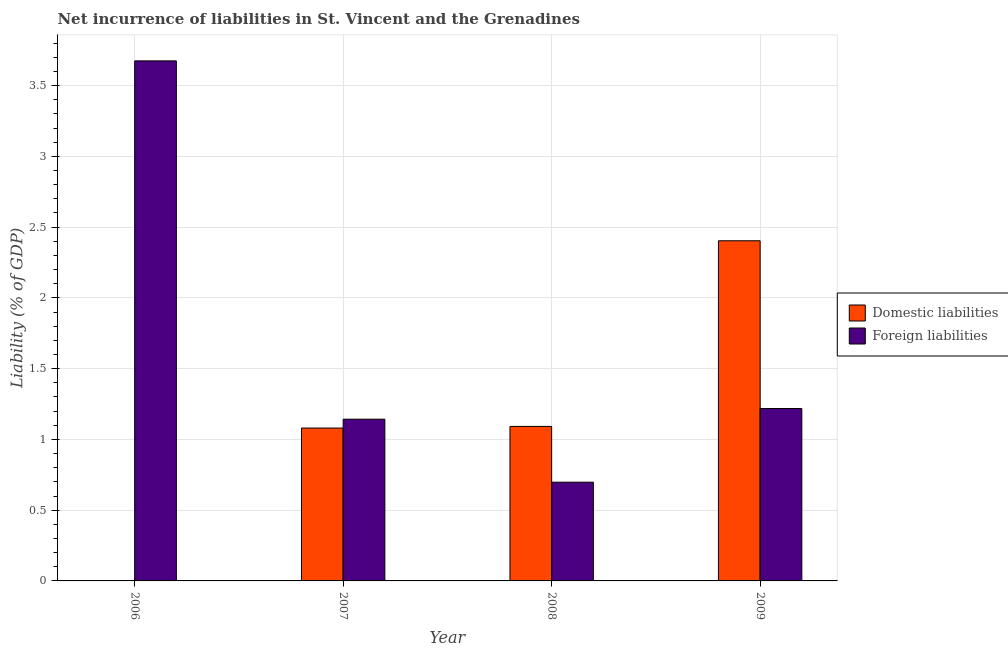Are the number of bars on each tick of the X-axis equal?
Provide a short and direct response. No. How many bars are there on the 1st tick from the left?
Make the answer very short. 1. How many bars are there on the 2nd tick from the right?
Make the answer very short. 2. What is the label of the 4th group of bars from the left?
Provide a short and direct response. 2009. What is the incurrence of domestic liabilities in 2008?
Your answer should be compact. 1.09. Across all years, what is the maximum incurrence of foreign liabilities?
Your answer should be compact. 3.67. Across all years, what is the minimum incurrence of foreign liabilities?
Keep it short and to the point. 0.7. In which year was the incurrence of foreign liabilities maximum?
Your answer should be compact. 2006. What is the total incurrence of domestic liabilities in the graph?
Your answer should be compact. 4.58. What is the difference between the incurrence of foreign liabilities in 2007 and that in 2008?
Give a very brief answer. 0.45. What is the difference between the incurrence of domestic liabilities in 2009 and the incurrence of foreign liabilities in 2008?
Your response must be concise. 1.31. What is the average incurrence of foreign liabilities per year?
Offer a terse response. 1.68. In the year 2009, what is the difference between the incurrence of domestic liabilities and incurrence of foreign liabilities?
Provide a short and direct response. 0. In how many years, is the incurrence of foreign liabilities greater than 1.8 %?
Make the answer very short. 1. What is the ratio of the incurrence of domestic liabilities in 2007 to that in 2008?
Offer a very short reply. 0.99. Is the incurrence of foreign liabilities in 2008 less than that in 2009?
Ensure brevity in your answer.  Yes. What is the difference between the highest and the second highest incurrence of foreign liabilities?
Your answer should be very brief. 2.46. What is the difference between the highest and the lowest incurrence of domestic liabilities?
Keep it short and to the point. 2.4. Is the sum of the incurrence of foreign liabilities in 2008 and 2009 greater than the maximum incurrence of domestic liabilities across all years?
Ensure brevity in your answer.  No. How many bars are there?
Provide a short and direct response. 7. Are all the bars in the graph horizontal?
Provide a short and direct response. No. What is the difference between two consecutive major ticks on the Y-axis?
Ensure brevity in your answer.  0.5. Does the graph contain any zero values?
Ensure brevity in your answer.  Yes. Does the graph contain grids?
Give a very brief answer. Yes. Where does the legend appear in the graph?
Offer a terse response. Center right. What is the title of the graph?
Provide a short and direct response. Net incurrence of liabilities in St. Vincent and the Grenadines. Does "Secondary" appear as one of the legend labels in the graph?
Provide a succinct answer. No. What is the label or title of the Y-axis?
Give a very brief answer. Liability (% of GDP). What is the Liability (% of GDP) in Domestic liabilities in 2006?
Your response must be concise. 0. What is the Liability (% of GDP) of Foreign liabilities in 2006?
Offer a very short reply. 3.67. What is the Liability (% of GDP) in Domestic liabilities in 2007?
Offer a terse response. 1.08. What is the Liability (% of GDP) in Foreign liabilities in 2007?
Keep it short and to the point. 1.14. What is the Liability (% of GDP) in Domestic liabilities in 2008?
Provide a succinct answer. 1.09. What is the Liability (% of GDP) in Foreign liabilities in 2008?
Keep it short and to the point. 0.7. What is the Liability (% of GDP) of Domestic liabilities in 2009?
Make the answer very short. 2.4. What is the Liability (% of GDP) in Foreign liabilities in 2009?
Offer a very short reply. 1.22. Across all years, what is the maximum Liability (% of GDP) of Domestic liabilities?
Your response must be concise. 2.4. Across all years, what is the maximum Liability (% of GDP) in Foreign liabilities?
Your response must be concise. 3.67. Across all years, what is the minimum Liability (% of GDP) of Domestic liabilities?
Provide a short and direct response. 0. Across all years, what is the minimum Liability (% of GDP) in Foreign liabilities?
Offer a very short reply. 0.7. What is the total Liability (% of GDP) of Domestic liabilities in the graph?
Offer a terse response. 4.58. What is the total Liability (% of GDP) in Foreign liabilities in the graph?
Keep it short and to the point. 6.73. What is the difference between the Liability (% of GDP) in Foreign liabilities in 2006 and that in 2007?
Provide a succinct answer. 2.53. What is the difference between the Liability (% of GDP) of Foreign liabilities in 2006 and that in 2008?
Make the answer very short. 2.98. What is the difference between the Liability (% of GDP) of Foreign liabilities in 2006 and that in 2009?
Your answer should be very brief. 2.46. What is the difference between the Liability (% of GDP) of Domestic liabilities in 2007 and that in 2008?
Keep it short and to the point. -0.01. What is the difference between the Liability (% of GDP) of Foreign liabilities in 2007 and that in 2008?
Your answer should be very brief. 0.45. What is the difference between the Liability (% of GDP) of Domestic liabilities in 2007 and that in 2009?
Keep it short and to the point. -1.32. What is the difference between the Liability (% of GDP) of Foreign liabilities in 2007 and that in 2009?
Ensure brevity in your answer.  -0.08. What is the difference between the Liability (% of GDP) in Domestic liabilities in 2008 and that in 2009?
Your answer should be compact. -1.31. What is the difference between the Liability (% of GDP) of Foreign liabilities in 2008 and that in 2009?
Provide a short and direct response. -0.52. What is the difference between the Liability (% of GDP) in Domestic liabilities in 2007 and the Liability (% of GDP) in Foreign liabilities in 2008?
Give a very brief answer. 0.38. What is the difference between the Liability (% of GDP) of Domestic liabilities in 2007 and the Liability (% of GDP) of Foreign liabilities in 2009?
Keep it short and to the point. -0.14. What is the difference between the Liability (% of GDP) in Domestic liabilities in 2008 and the Liability (% of GDP) in Foreign liabilities in 2009?
Give a very brief answer. -0.13. What is the average Liability (% of GDP) in Domestic liabilities per year?
Keep it short and to the point. 1.14. What is the average Liability (% of GDP) of Foreign liabilities per year?
Provide a succinct answer. 1.68. In the year 2007, what is the difference between the Liability (% of GDP) of Domestic liabilities and Liability (% of GDP) of Foreign liabilities?
Ensure brevity in your answer.  -0.06. In the year 2008, what is the difference between the Liability (% of GDP) in Domestic liabilities and Liability (% of GDP) in Foreign liabilities?
Offer a terse response. 0.39. In the year 2009, what is the difference between the Liability (% of GDP) of Domestic liabilities and Liability (% of GDP) of Foreign liabilities?
Provide a succinct answer. 1.19. What is the ratio of the Liability (% of GDP) in Foreign liabilities in 2006 to that in 2007?
Ensure brevity in your answer.  3.22. What is the ratio of the Liability (% of GDP) of Foreign liabilities in 2006 to that in 2008?
Provide a short and direct response. 5.27. What is the ratio of the Liability (% of GDP) in Foreign liabilities in 2006 to that in 2009?
Give a very brief answer. 3.02. What is the ratio of the Liability (% of GDP) in Foreign liabilities in 2007 to that in 2008?
Make the answer very short. 1.64. What is the ratio of the Liability (% of GDP) in Domestic liabilities in 2007 to that in 2009?
Ensure brevity in your answer.  0.45. What is the ratio of the Liability (% of GDP) in Foreign liabilities in 2007 to that in 2009?
Keep it short and to the point. 0.94. What is the ratio of the Liability (% of GDP) in Domestic liabilities in 2008 to that in 2009?
Make the answer very short. 0.45. What is the ratio of the Liability (% of GDP) in Foreign liabilities in 2008 to that in 2009?
Make the answer very short. 0.57. What is the difference between the highest and the second highest Liability (% of GDP) in Domestic liabilities?
Provide a succinct answer. 1.31. What is the difference between the highest and the second highest Liability (% of GDP) of Foreign liabilities?
Provide a succinct answer. 2.46. What is the difference between the highest and the lowest Liability (% of GDP) of Domestic liabilities?
Your response must be concise. 2.4. What is the difference between the highest and the lowest Liability (% of GDP) of Foreign liabilities?
Your answer should be very brief. 2.98. 